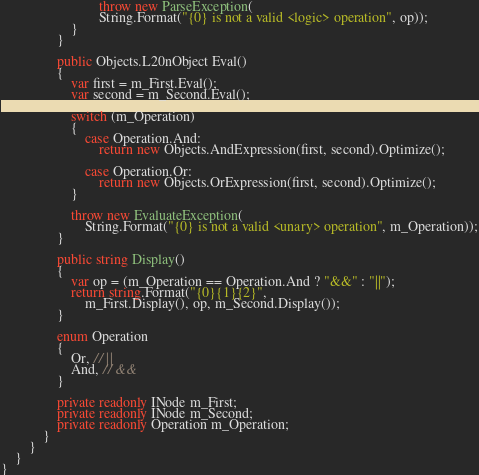Convert code to text. <code><loc_0><loc_0><loc_500><loc_500><_C#_>							throw new ParseException(
							String.Format("{0} is not a valid <logic> operation", op));
					}
				}
				
				public Objects.L20nObject Eval()
				{
					var first = m_First.Eval();
					var second = m_Second.Eval();
					
					switch (m_Operation)
					{
						case Operation.And:
							return new Objects.AndExpression(first, second).Optimize();
						
						case Operation.Or:
							return new Objects.OrExpression(first, second).Optimize();
					}
					
					throw new EvaluateException(
						String.Format("{0} is not a valid <unary> operation", m_Operation));
				}
				
				public string Display()
				{
					var op = (m_Operation == Operation.And ? "&&" : "||");
					return string.Format("{0}{1}{2}",
						m_First.Display(), op, m_Second.Display());
				}
				
				enum Operation
				{
					Or, // ||
					And, // &&
				}

				private readonly INode m_First;
				private readonly INode m_Second;
				private readonly Operation m_Operation;
			}
		}
	}
}
</code> 